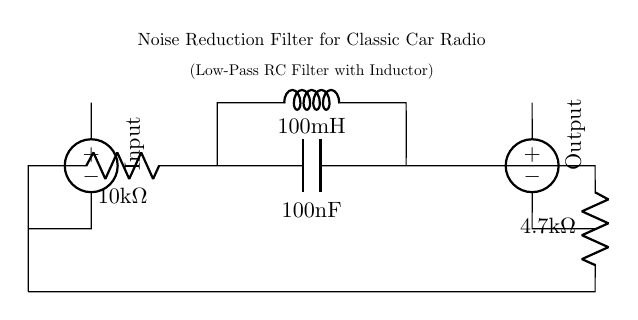What type of filter is shown in the circuit? This circuit is specifically designed as a low-pass filter, which allows low-frequency signals to pass through while attenuating higher frequencies. The presence of a resistor, capacitor, and inductor indicates it is indeed a low-pass configuration.
Answer: Low-pass filter What is the value of the first resistor in the circuit? The first resistor (R1) is identified in the diagram, labeled with a value of ten thousand ohms. This value is crucial for controlling the filter's cutoff frequency along with the capacitor.
Answer: 10 kΩ How many components are used in this noise reduction filter? The circuit contains five main components: two resistors, one capacitor, and one inductor, along with two voltage sources for input and output. Each of these parts contributes to the functionality of the filter.
Answer: Five What is the inductance value of the inductor in the circuit? The inductor (L1) is clearly marked in the diagram with a value of one hundred millihenries, which is significant for the frequency response of the filter.
Answer: 100 mH What type of source is used for the input in this circuit? The input is provided from an American voltage source, indicated in the circuit with a specific label. This source is necessary to power the filter for appropriate operation.
Answer: American voltage source How does the resistor and capacitor affect the cutoff frequency? The resistor and capacitor together determine the cutoff frequency of the filter through the formula involving their values. The cutoff frequency is where the filter starts to attenuate frequencies, calculated as one over two pi times the product of resistance in ohms and capacitance in farads.
Answer: Attenuate frequencies What effect does this noise reduction filter have on the radio signals? This filter reduces unwanted high-frequency noise from signals, which enhances the clarity and quality of the audio output from classic car radios. This is crucial for better reception and sound quality.
Answer: Reduces unwanted noise 